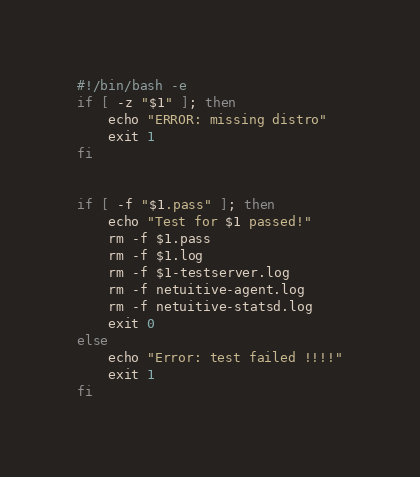Convert code to text. <code><loc_0><loc_0><loc_500><loc_500><_Bash_>#!/bin/bash -e
if [ -z "$1" ]; then
    echo "ERROR: missing distro"
    exit 1
fi


if [ -f "$1.pass" ]; then
    echo "Test for $1 passed!"
    rm -f $1.pass
    rm -f $1.log
    rm -f $1-testserver.log
    rm -f netuitive-agent.log
    rm -f netuitive-statsd.log
    exit 0
else
    echo "Error: test failed !!!!"
    exit 1
fi</code> 